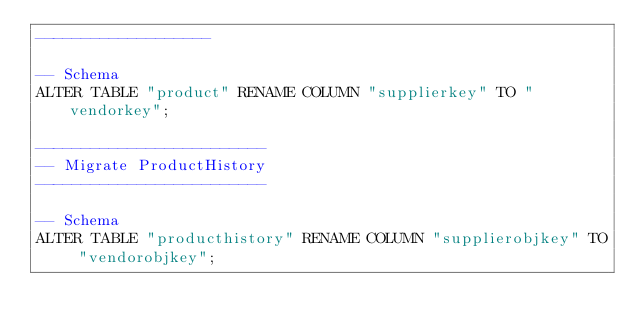Convert code to text. <code><loc_0><loc_0><loc_500><loc_500><_SQL_>-------------------

-- Schema
ALTER TABLE "product" RENAME COLUMN "supplierkey" TO "vendorkey";

-------------------------
-- Migrate ProductHistory
-------------------------

-- Schema
ALTER TABLE "producthistory" RENAME COLUMN "supplierobjkey" TO "vendorobjkey";
</code> 